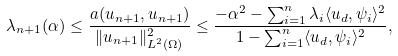<formula> <loc_0><loc_0><loc_500><loc_500>\lambda _ { n + 1 } ( \alpha ) \leq \frac { a ( u _ { n + 1 } , u _ { n + 1 } ) } { \| u _ { n + 1 } \| _ { L ^ { 2 } ( \Omega ) } ^ { 2 } } \leq \frac { - \alpha ^ { 2 } - \sum _ { i = 1 } ^ { n } \lambda _ { i } \langle u _ { d } , \psi _ { i } \rangle ^ { 2 } } { 1 - \sum _ { i = 1 } ^ { n } \langle u _ { d } , \psi _ { i } \rangle ^ { 2 } } ,</formula> 